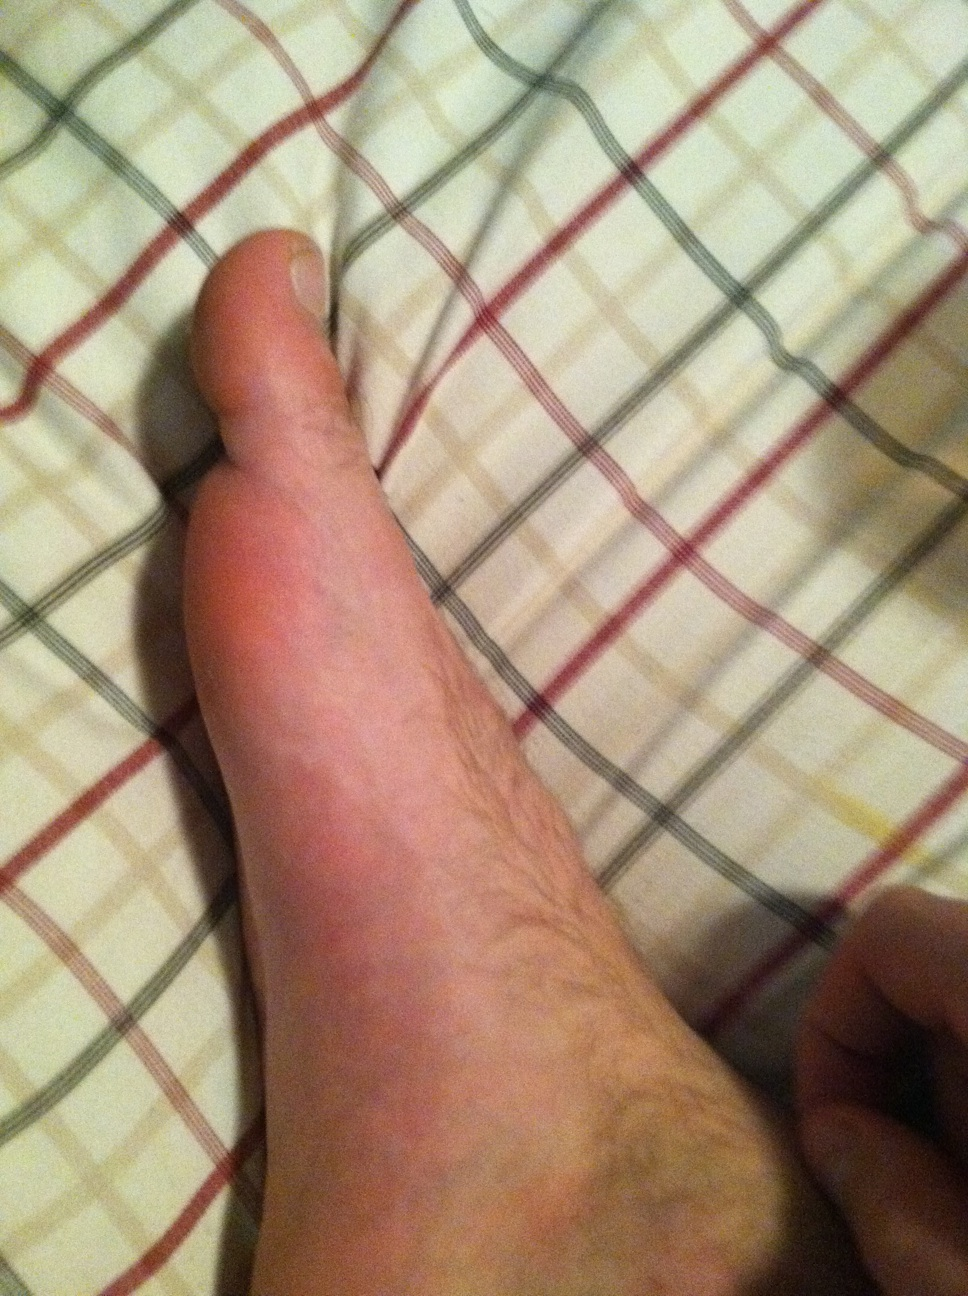What color is my skin? The skin color in the image appears to be a light beige or a pale peach tone, typical for a person with fair skin. 